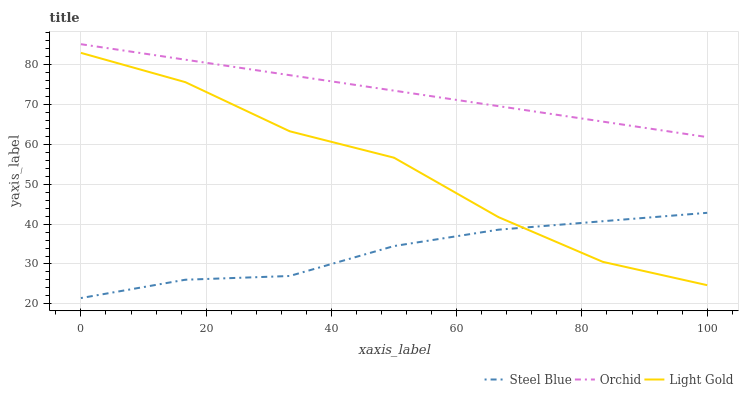Does Steel Blue have the minimum area under the curve?
Answer yes or no. Yes. Does Orchid have the maximum area under the curve?
Answer yes or no. Yes. Does Orchid have the minimum area under the curve?
Answer yes or no. No. Does Steel Blue have the maximum area under the curve?
Answer yes or no. No. Is Orchid the smoothest?
Answer yes or no. Yes. Is Light Gold the roughest?
Answer yes or no. Yes. Is Steel Blue the smoothest?
Answer yes or no. No. Is Steel Blue the roughest?
Answer yes or no. No. Does Steel Blue have the lowest value?
Answer yes or no. Yes. Does Orchid have the lowest value?
Answer yes or no. No. Does Orchid have the highest value?
Answer yes or no. Yes. Does Steel Blue have the highest value?
Answer yes or no. No. Is Light Gold less than Orchid?
Answer yes or no. Yes. Is Orchid greater than Light Gold?
Answer yes or no. Yes. Does Light Gold intersect Steel Blue?
Answer yes or no. Yes. Is Light Gold less than Steel Blue?
Answer yes or no. No. Is Light Gold greater than Steel Blue?
Answer yes or no. No. Does Light Gold intersect Orchid?
Answer yes or no. No. 